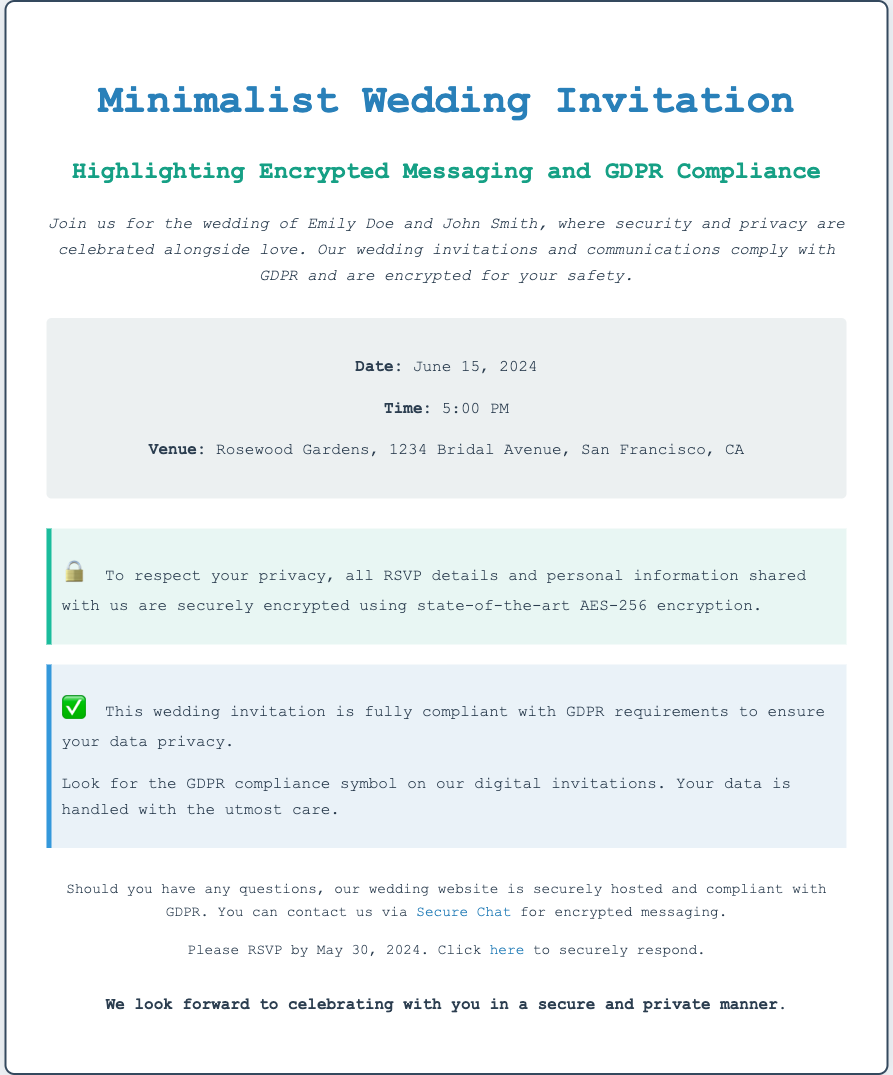What is the date of the wedding? The date of the wedding is explicitly mentioned in the details section of the invitation.
Answer: June 15, 2024 What is the venue for the wedding? The venue is listed clearly in the details section of the document.
Answer: Rosewood Gardens, 1234 Bridal Avenue, San Francisco, CA What time does the wedding start? The start time for the wedding is provided in the details section.
Answer: 5:00 PM What encryption method is used for RSVP details? The invitation specifically states the encryption method in the encryption notice.
Answer: AES-256 How should guests contact the couple for questions? The invitation provides a specific method for contact in the additional notes section.
Answer: Secure Chat What does the GDPR compliance symbol signify? The invitation explains the importance of the GDPR compliance symbol in relation to data privacy.
Answer: Data privacy assurance What is the RSVP deadline? The RSVP deadline is clearly stated in the additional notes section of the invitation.
Answer: May 30, 2024 What should guests look for on digital invitations? The invitation indicates something important regarding digital invitations.
Answer: GDPR compliance symbol What theme is highlighted in this wedding invitation? The invitation emphasizes a specific theme throughout its content.
Answer: Minimalist Wedding 